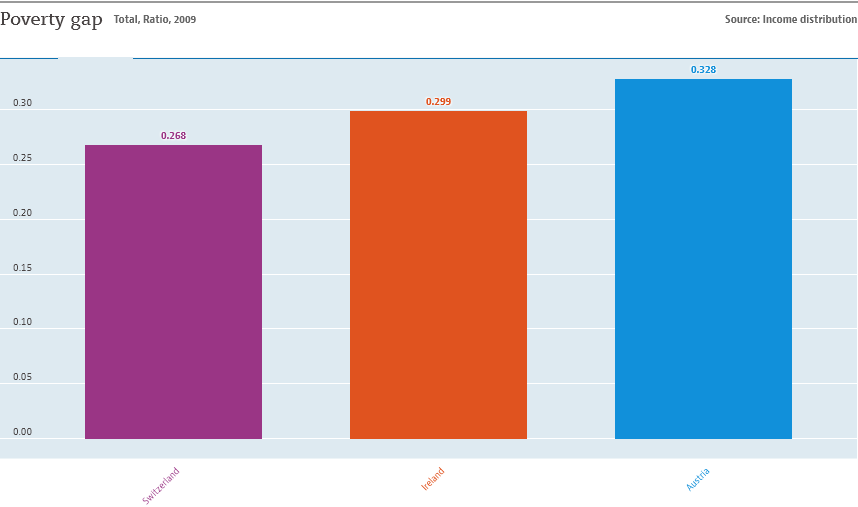Point out several critical features in this image. The largest bar is blue in color. Ireland represents the median value of a country. 